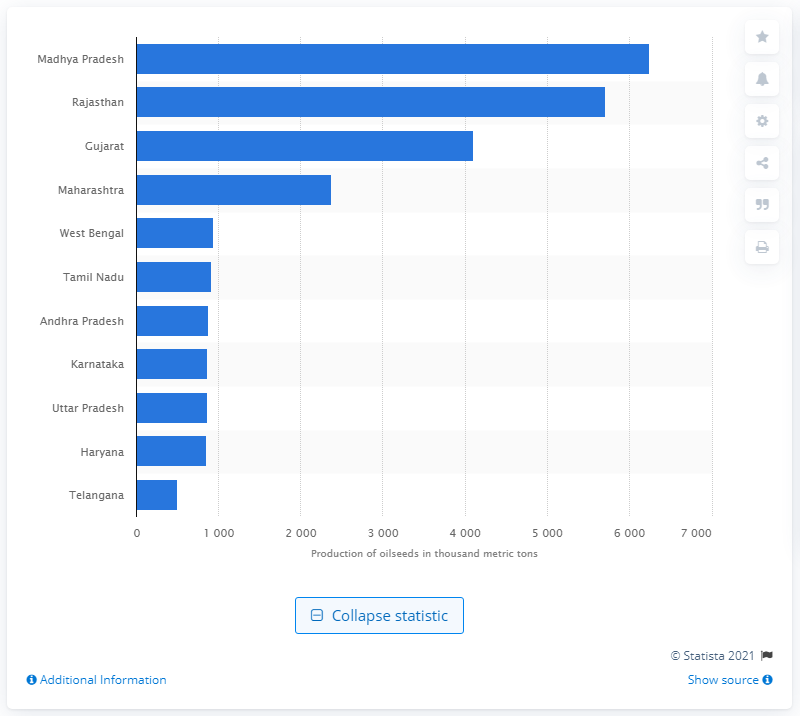Identify some key points in this picture. According to the fiscal year 2016 statistics, Madhya Pradesh was the state in India that produced the highest quantity of oilseeds. 